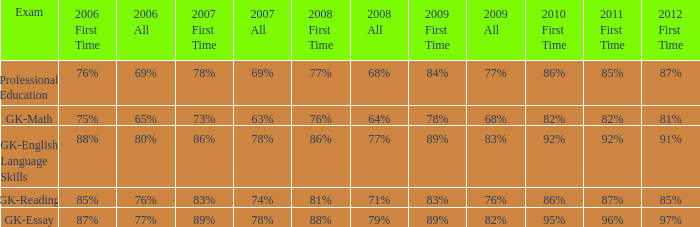What is the percentage for first time 2011 when the first time in 2009 is 68%? 82%. 